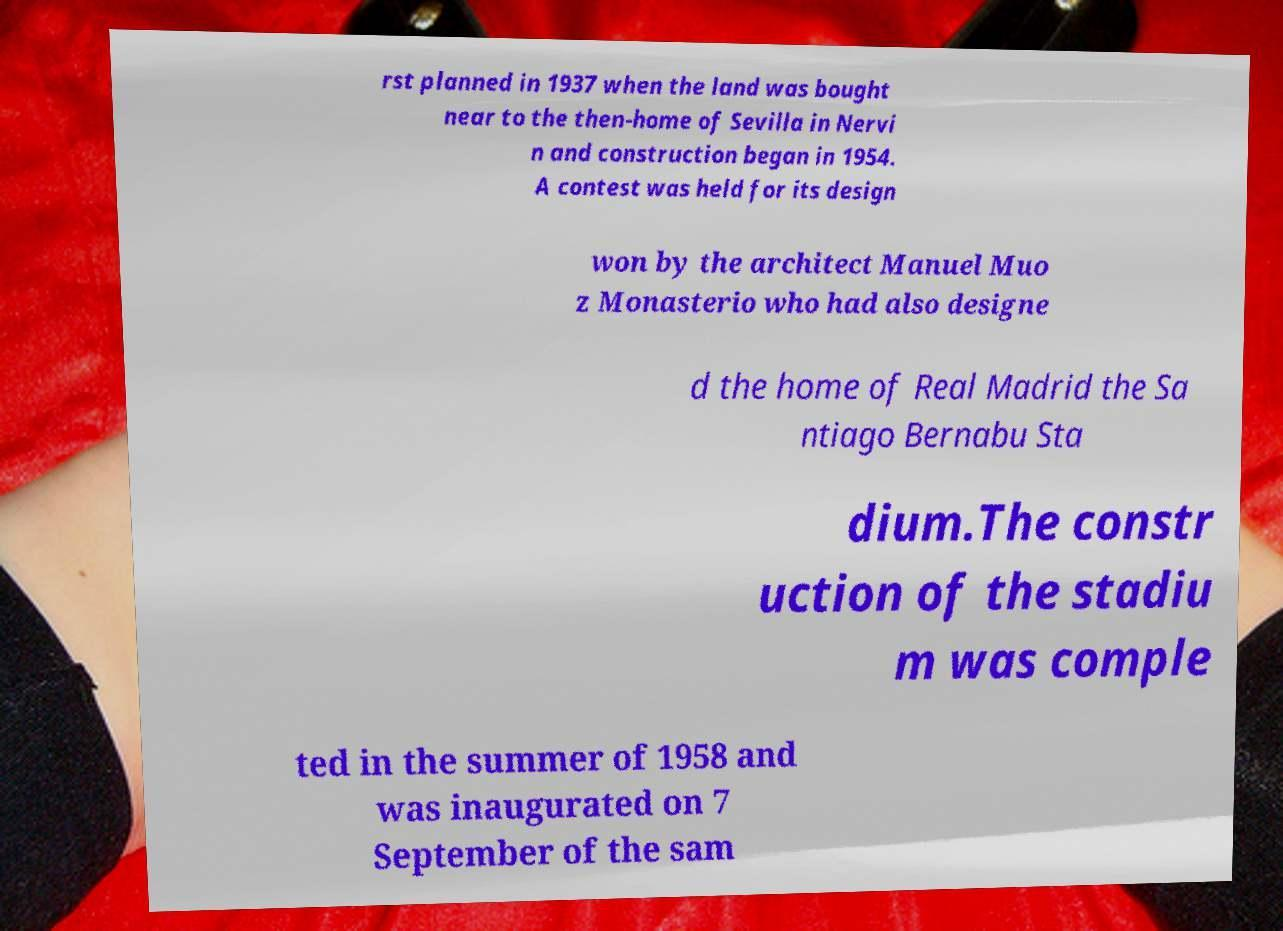Please read and relay the text visible in this image. What does it say? rst planned in 1937 when the land was bought near to the then-home of Sevilla in Nervi n and construction began in 1954. A contest was held for its design won by the architect Manuel Muo z Monasterio who had also designe d the home of Real Madrid the Sa ntiago Bernabu Sta dium.The constr uction of the stadiu m was comple ted in the summer of 1958 and was inaugurated on 7 September of the sam 